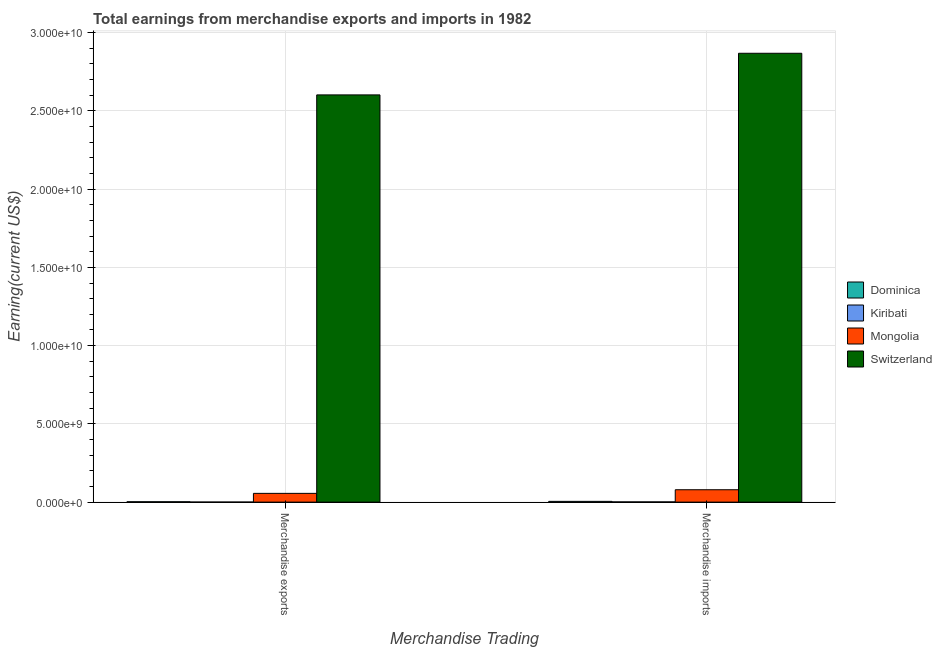How many bars are there on the 2nd tick from the left?
Provide a succinct answer. 4. What is the earnings from merchandise imports in Dominica?
Offer a very short reply. 4.80e+07. Across all countries, what is the maximum earnings from merchandise exports?
Keep it short and to the point. 2.60e+1. Across all countries, what is the minimum earnings from merchandise exports?
Provide a succinct answer. 2.00e+06. In which country was the earnings from merchandise exports maximum?
Give a very brief answer. Switzerland. In which country was the earnings from merchandise exports minimum?
Keep it short and to the point. Kiribati. What is the total earnings from merchandise exports in the graph?
Provide a succinct answer. 2.66e+1. What is the difference between the earnings from merchandise imports in Dominica and that in Switzerland?
Keep it short and to the point. -2.86e+1. What is the difference between the earnings from merchandise imports in Kiribati and the earnings from merchandise exports in Mongolia?
Offer a very short reply. -5.46e+08. What is the average earnings from merchandise exports per country?
Provide a succinct answer. 6.65e+09. What is the difference between the earnings from merchandise exports and earnings from merchandise imports in Kiribati?
Provide a succinct answer. -1.20e+07. In how many countries, is the earnings from merchandise exports greater than 22000000000 US$?
Make the answer very short. 1. What is the ratio of the earnings from merchandise imports in Dominica to that in Kiribati?
Your answer should be very brief. 3.43. In how many countries, is the earnings from merchandise exports greater than the average earnings from merchandise exports taken over all countries?
Your response must be concise. 1. What does the 2nd bar from the left in Merchandise imports represents?
Your response must be concise. Kiribati. What does the 3rd bar from the right in Merchandise exports represents?
Your answer should be very brief. Kiribati. Are all the bars in the graph horizontal?
Provide a succinct answer. No. How many countries are there in the graph?
Provide a short and direct response. 4. Does the graph contain any zero values?
Your answer should be compact. No. How are the legend labels stacked?
Offer a terse response. Vertical. What is the title of the graph?
Your answer should be compact. Total earnings from merchandise exports and imports in 1982. What is the label or title of the X-axis?
Your response must be concise. Merchandise Trading. What is the label or title of the Y-axis?
Provide a succinct answer. Earning(current US$). What is the Earning(current US$) of Dominica in Merchandise exports?
Your answer should be compact. 2.40e+07. What is the Earning(current US$) in Kiribati in Merchandise exports?
Ensure brevity in your answer.  2.00e+06. What is the Earning(current US$) of Mongolia in Merchandise exports?
Your answer should be compact. 5.60e+08. What is the Earning(current US$) in Switzerland in Merchandise exports?
Offer a very short reply. 2.60e+1. What is the Earning(current US$) of Dominica in Merchandise imports?
Provide a short and direct response. 4.80e+07. What is the Earning(current US$) in Kiribati in Merchandise imports?
Your answer should be very brief. 1.40e+07. What is the Earning(current US$) of Mongolia in Merchandise imports?
Ensure brevity in your answer.  7.91e+08. What is the Earning(current US$) of Switzerland in Merchandise imports?
Your answer should be very brief. 2.87e+1. Across all Merchandise Trading, what is the maximum Earning(current US$) of Dominica?
Keep it short and to the point. 4.80e+07. Across all Merchandise Trading, what is the maximum Earning(current US$) in Kiribati?
Provide a short and direct response. 1.40e+07. Across all Merchandise Trading, what is the maximum Earning(current US$) in Mongolia?
Your answer should be compact. 7.91e+08. Across all Merchandise Trading, what is the maximum Earning(current US$) in Switzerland?
Your response must be concise. 2.87e+1. Across all Merchandise Trading, what is the minimum Earning(current US$) in Dominica?
Provide a succinct answer. 2.40e+07. Across all Merchandise Trading, what is the minimum Earning(current US$) in Mongolia?
Offer a very short reply. 5.60e+08. Across all Merchandise Trading, what is the minimum Earning(current US$) in Switzerland?
Your answer should be compact. 2.60e+1. What is the total Earning(current US$) of Dominica in the graph?
Your response must be concise. 7.20e+07. What is the total Earning(current US$) in Kiribati in the graph?
Your answer should be compact. 1.60e+07. What is the total Earning(current US$) of Mongolia in the graph?
Your answer should be compact. 1.35e+09. What is the total Earning(current US$) in Switzerland in the graph?
Give a very brief answer. 5.47e+1. What is the difference between the Earning(current US$) in Dominica in Merchandise exports and that in Merchandise imports?
Give a very brief answer. -2.40e+07. What is the difference between the Earning(current US$) in Kiribati in Merchandise exports and that in Merchandise imports?
Your answer should be compact. -1.20e+07. What is the difference between the Earning(current US$) of Mongolia in Merchandise exports and that in Merchandise imports?
Offer a terse response. -2.31e+08. What is the difference between the Earning(current US$) in Switzerland in Merchandise exports and that in Merchandise imports?
Give a very brief answer. -2.66e+09. What is the difference between the Earning(current US$) in Dominica in Merchandise exports and the Earning(current US$) in Kiribati in Merchandise imports?
Your answer should be very brief. 1.00e+07. What is the difference between the Earning(current US$) of Dominica in Merchandise exports and the Earning(current US$) of Mongolia in Merchandise imports?
Offer a terse response. -7.67e+08. What is the difference between the Earning(current US$) in Dominica in Merchandise exports and the Earning(current US$) in Switzerland in Merchandise imports?
Offer a very short reply. -2.87e+1. What is the difference between the Earning(current US$) of Kiribati in Merchandise exports and the Earning(current US$) of Mongolia in Merchandise imports?
Give a very brief answer. -7.89e+08. What is the difference between the Earning(current US$) in Kiribati in Merchandise exports and the Earning(current US$) in Switzerland in Merchandise imports?
Make the answer very short. -2.87e+1. What is the difference between the Earning(current US$) in Mongolia in Merchandise exports and the Earning(current US$) in Switzerland in Merchandise imports?
Offer a very short reply. -2.81e+1. What is the average Earning(current US$) in Dominica per Merchandise Trading?
Make the answer very short. 3.60e+07. What is the average Earning(current US$) of Kiribati per Merchandise Trading?
Make the answer very short. 8.00e+06. What is the average Earning(current US$) in Mongolia per Merchandise Trading?
Offer a very short reply. 6.76e+08. What is the average Earning(current US$) of Switzerland per Merchandise Trading?
Provide a succinct answer. 2.73e+1. What is the difference between the Earning(current US$) of Dominica and Earning(current US$) of Kiribati in Merchandise exports?
Offer a terse response. 2.20e+07. What is the difference between the Earning(current US$) of Dominica and Earning(current US$) of Mongolia in Merchandise exports?
Your response must be concise. -5.36e+08. What is the difference between the Earning(current US$) in Dominica and Earning(current US$) in Switzerland in Merchandise exports?
Give a very brief answer. -2.60e+1. What is the difference between the Earning(current US$) of Kiribati and Earning(current US$) of Mongolia in Merchandise exports?
Offer a terse response. -5.58e+08. What is the difference between the Earning(current US$) of Kiribati and Earning(current US$) of Switzerland in Merchandise exports?
Your answer should be very brief. -2.60e+1. What is the difference between the Earning(current US$) of Mongolia and Earning(current US$) of Switzerland in Merchandise exports?
Your response must be concise. -2.55e+1. What is the difference between the Earning(current US$) of Dominica and Earning(current US$) of Kiribati in Merchandise imports?
Provide a succinct answer. 3.40e+07. What is the difference between the Earning(current US$) of Dominica and Earning(current US$) of Mongolia in Merchandise imports?
Make the answer very short. -7.43e+08. What is the difference between the Earning(current US$) of Dominica and Earning(current US$) of Switzerland in Merchandise imports?
Make the answer very short. -2.86e+1. What is the difference between the Earning(current US$) of Kiribati and Earning(current US$) of Mongolia in Merchandise imports?
Provide a short and direct response. -7.77e+08. What is the difference between the Earning(current US$) of Kiribati and Earning(current US$) of Switzerland in Merchandise imports?
Keep it short and to the point. -2.87e+1. What is the difference between the Earning(current US$) of Mongolia and Earning(current US$) of Switzerland in Merchandise imports?
Offer a very short reply. -2.79e+1. What is the ratio of the Earning(current US$) of Kiribati in Merchandise exports to that in Merchandise imports?
Offer a terse response. 0.14. What is the ratio of the Earning(current US$) of Mongolia in Merchandise exports to that in Merchandise imports?
Give a very brief answer. 0.71. What is the ratio of the Earning(current US$) of Switzerland in Merchandise exports to that in Merchandise imports?
Offer a very short reply. 0.91. What is the difference between the highest and the second highest Earning(current US$) in Dominica?
Provide a succinct answer. 2.40e+07. What is the difference between the highest and the second highest Earning(current US$) in Mongolia?
Your answer should be very brief. 2.31e+08. What is the difference between the highest and the second highest Earning(current US$) in Switzerland?
Give a very brief answer. 2.66e+09. What is the difference between the highest and the lowest Earning(current US$) of Dominica?
Keep it short and to the point. 2.40e+07. What is the difference between the highest and the lowest Earning(current US$) of Kiribati?
Offer a terse response. 1.20e+07. What is the difference between the highest and the lowest Earning(current US$) of Mongolia?
Offer a terse response. 2.31e+08. What is the difference between the highest and the lowest Earning(current US$) in Switzerland?
Keep it short and to the point. 2.66e+09. 